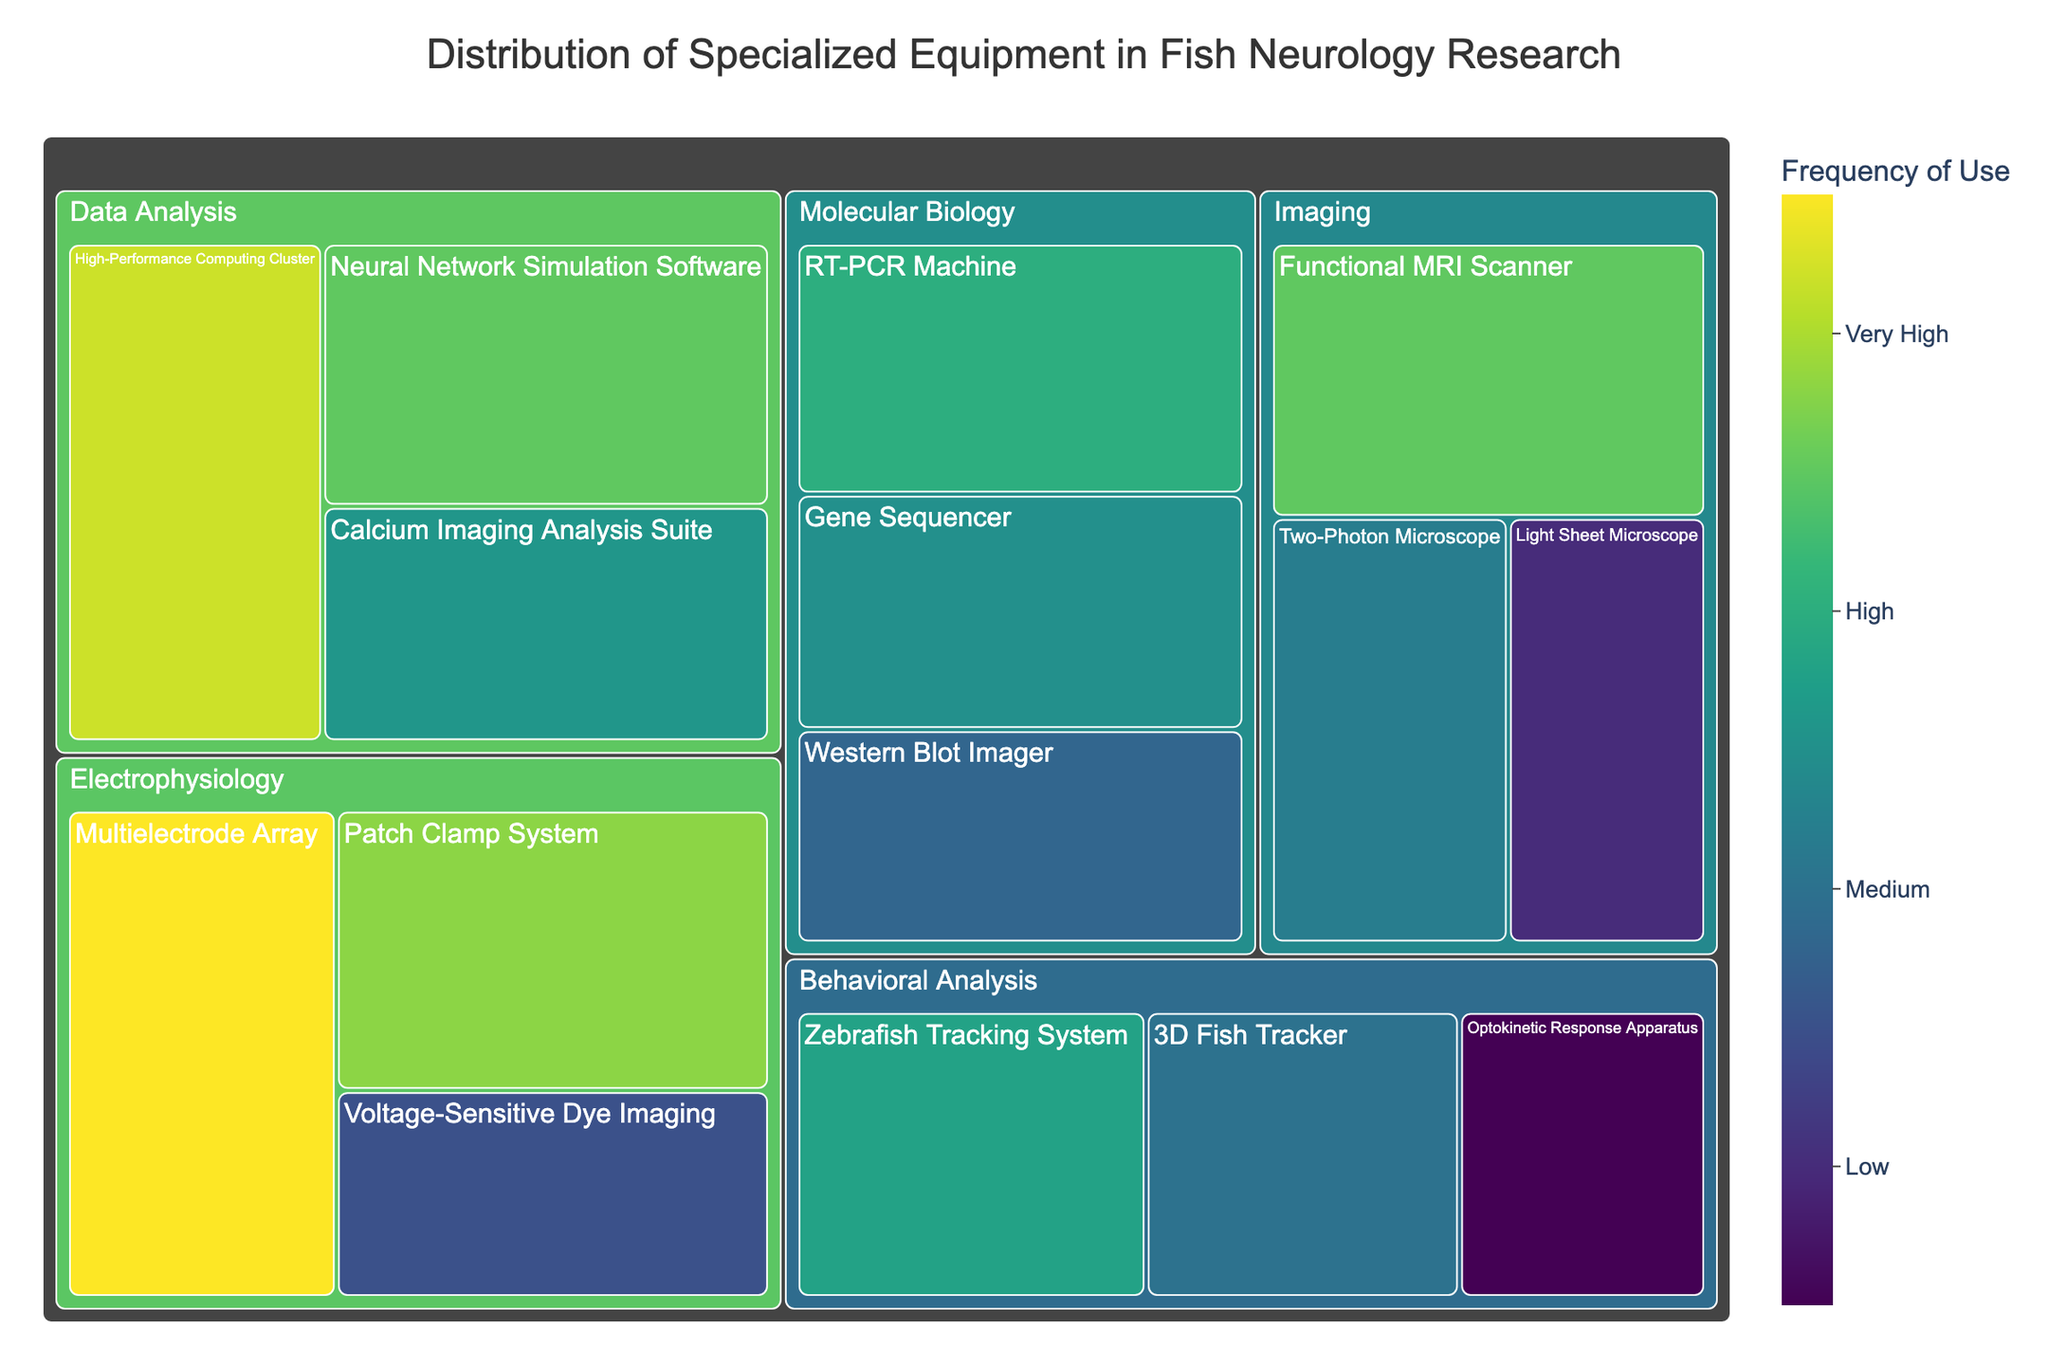What's the title of the figure? The title is usually displayed prominently at the top of the figure. In this case, the plot is titled "Distribution of Specialized Equipment in Fish Neurology Research."
Answer: Distribution of Specialized Equipment in Fish Neurology Research Which piece of electrophysiology equipment is used most frequently? The color intensity and the numerical value marked on the Treemap indicate frequency. The "Multielectrode Array" appears to be the most frequently used electrophysiology equipment with a frequency of 95.
Answer: Multielectrode Array How does the frequency of use for the Functional MRI Scanner compare to the Patch Clamp System? Look at the numerical values associated with both "Functional MRI Scanner" (85) and "Patch Clamp System" (88) on the Treemap. The Patch Clamp System has a higher frequency of use by 3 units.
Answer: Patch Clamp System What is the least frequently used type of equipment in the Behavioral Analysis category? By examining the smallest section under the Behavioral Analysis category and corresponding frequency values, the "Optokinetic Response Apparatus" with a frequency of 55 is the least used.
Answer: Optokinetic Response Apparatus What is the total frequency of use for all molecular biology equipment combined? Add the frequencies of the three pieces of equipment in the Molecular Biology category: RT-PCR Machine (80), Gene Sequencer (75), and Western Blot Imager (68). The sum is 80 + 75 + 68 = 223.
Answer: 223 Which category has the highest overall frequency of use among its equipment? Sum the frequencies of equipment within each category and compare the totals. Only "Electrophysiology" would have the highest combined frequency: 95 + 88 + 65 = 248.
Answer: Electrophysiology How does the frequency distribution of imaging equipment compare to data analysis equipment? Examine and compare the respective frequencies for Imaging (Functional MRI Scanner: 85, Two-Photon Microscope: 72, Light Sheet Microscope: 60) and Data Analysis (High-Performance Computing Cluster: 92, Neural Network Simulation Software: 85, Calcium Imaging Analysis Suite: 76). Imaging has a total frequency of 85 + 72 + 60 = 217, while Data Analysis totals 92 + 85 + 76 = 253. Thus, Data Analysis has a higher frequency aggregate.
Answer: Data Analysis Which two categories have the smallest difference in total equipment frequency? Compare the total frequencies for each category: Imaging (217), Electrophysiology (248), Behavioral Analysis (203), Molecular Biology (223), and Data Analysis (253). The smallest difference is between Imaging (217) and Molecular Biology (223), which is 6 units.
Answer: Imaging and Molecular Biology What is the average frequency of use for equipment in the Behavioral Analysis category? The Behavioral Analysis category includes three types of equipment: Zebrafish Tracking System (78), 3D Fish Tracker (70), and Optokinetic Response Apparatus (55). Calculate the average: (78 + 70 + 55) / 3 = 203 / 3 ≈ 67.67.
Answer: ~67.67 Which individual piece of equipment has the lowest frequency of use, and what category does it belong to? Identify the piece of equipment with the smallest numerical value on the Treemap. The "Optokinetic Response Apparatus" in the Behavioral Analysis category has the lowest frequency of 55.
Answer: Optokinetic Response Apparatus, Behavioral Analysis 